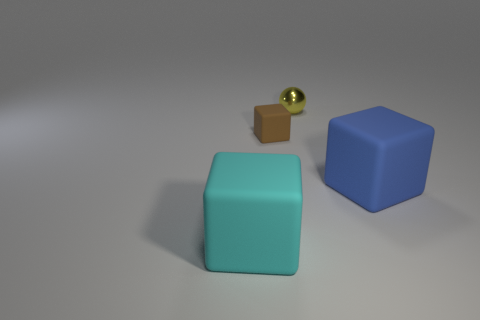There is a block that is both to the left of the large blue block and in front of the tiny matte cube; what is its material?
Provide a succinct answer. Rubber. How many cyan things are the same size as the yellow metal object?
Provide a succinct answer. 0. There is a cyan thing that is the same shape as the big blue thing; what is it made of?
Ensure brevity in your answer.  Rubber. What number of objects are cubes behind the big cyan rubber cube or large matte objects in front of the large blue rubber object?
Your answer should be compact. 3. There is a tiny brown object; is its shape the same as the big matte thing behind the large cyan matte object?
Your response must be concise. Yes. What is the shape of the big rubber object to the right of the object behind the brown thing that is in front of the small metallic thing?
Provide a short and direct response. Cube. What number of other objects are there of the same material as the large blue block?
Provide a short and direct response. 2. How many things are either blue objects in front of the yellow thing or small green balls?
Your answer should be very brief. 1. The matte thing behind the large cube behind the big cyan object is what shape?
Offer a very short reply. Cube. Does the big rubber object that is left of the tiny brown matte block have the same shape as the blue thing?
Keep it short and to the point. Yes. 